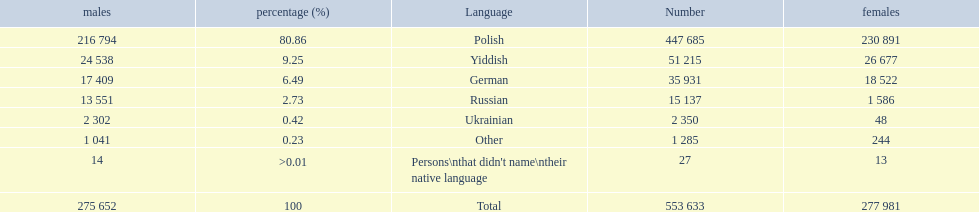What are all of the languages? Polish, Yiddish, German, Russian, Ukrainian, Other, Persons\nthat didn't name\ntheir native language. And how many people speak these languages? 447 685, 51 215, 35 931, 15 137, 2 350, 1 285, 27. Which language is used by most people? Polish. 